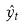<formula> <loc_0><loc_0><loc_500><loc_500>\hat { y } _ { t }</formula> 